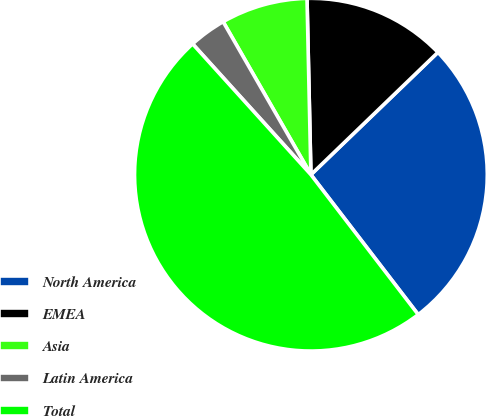Convert chart. <chart><loc_0><loc_0><loc_500><loc_500><pie_chart><fcel>North America<fcel>EMEA<fcel>Asia<fcel>Latin America<fcel>Total<nl><fcel>26.79%<fcel>13.15%<fcel>7.94%<fcel>3.41%<fcel>48.71%<nl></chart> 